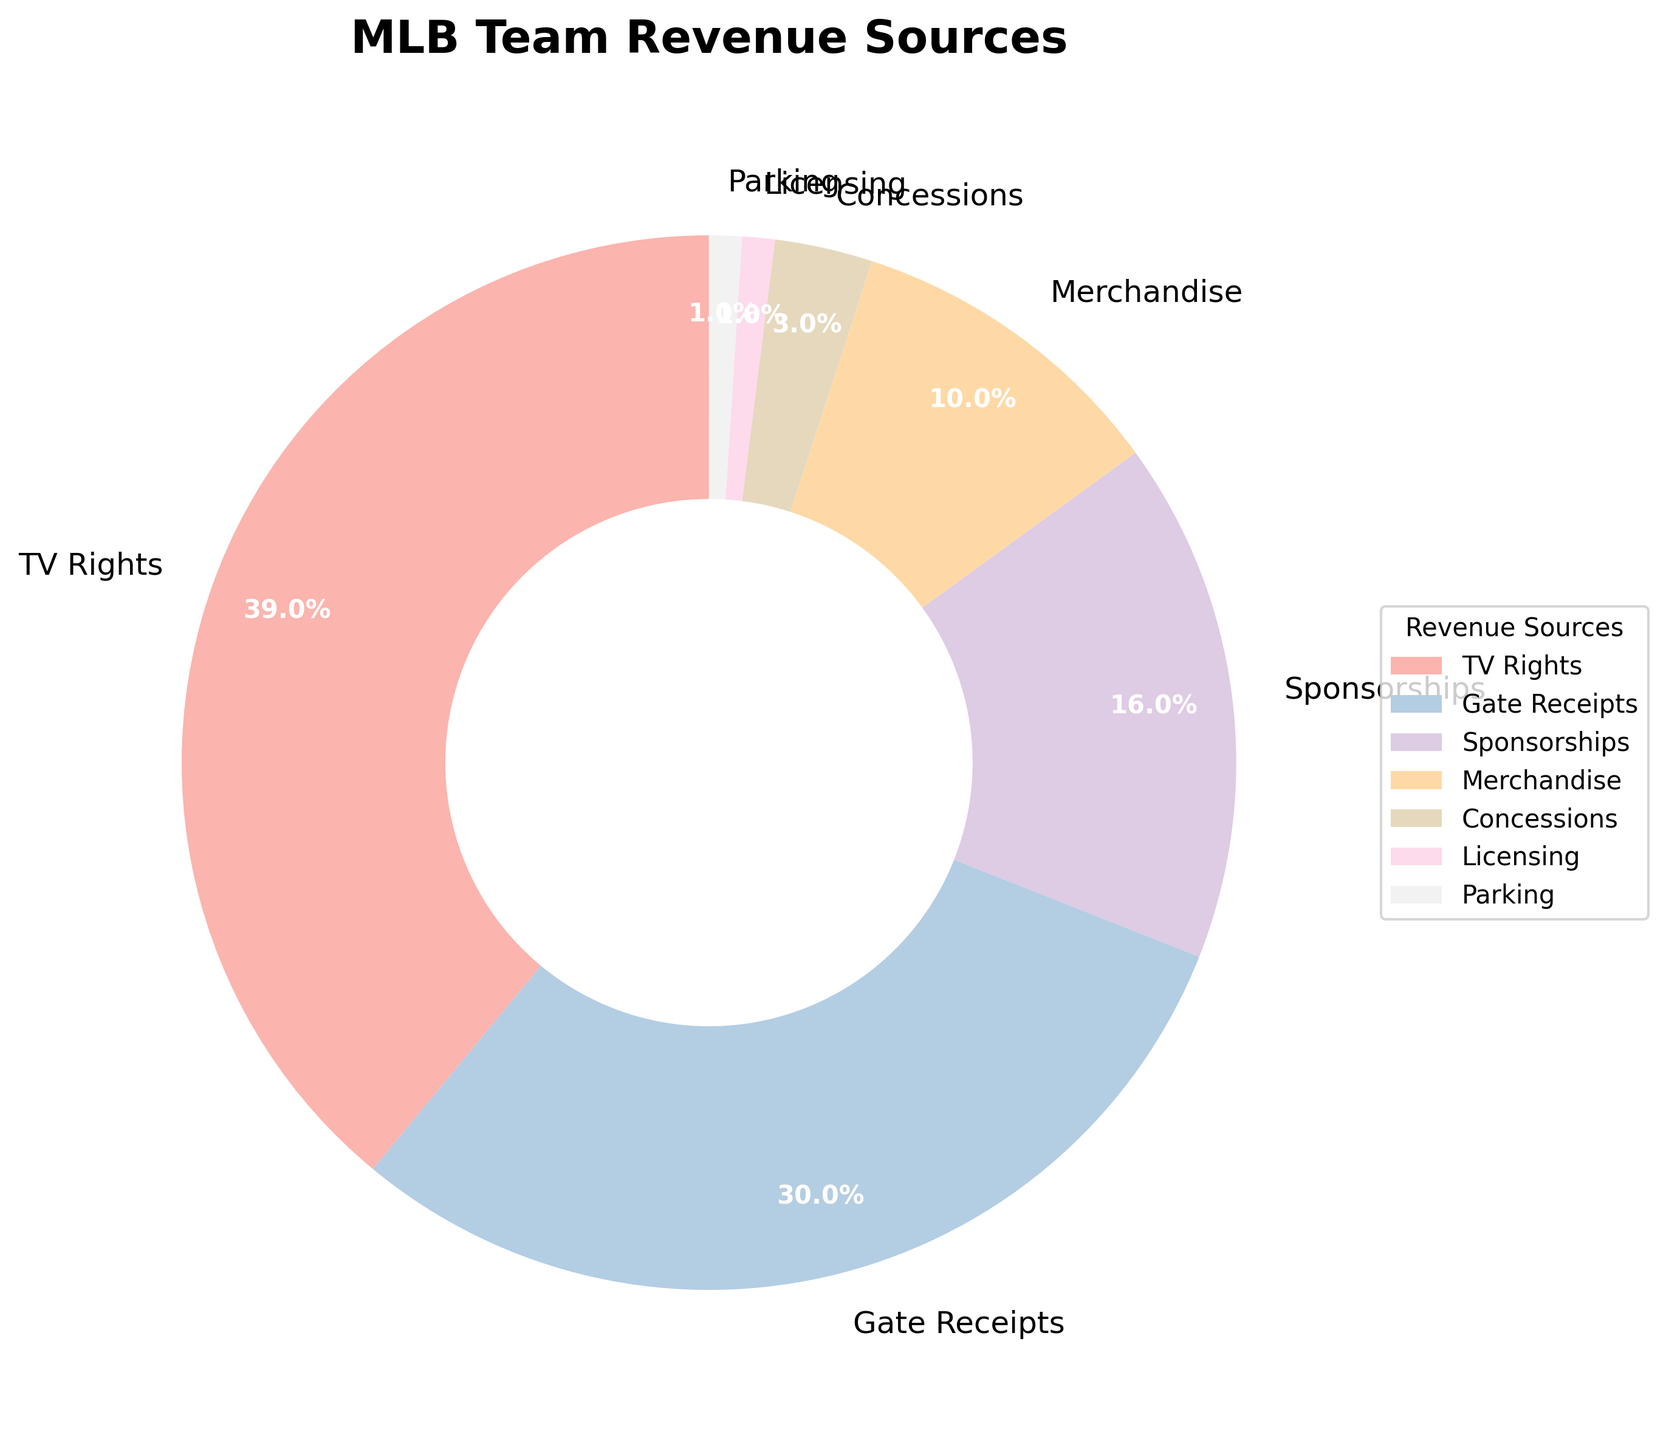Which revenue source contributes the most to MLB team revenue? The pie chart shows various revenue sources with their percentages. The largest wedge represents the highest contributor, which is TV Rights at 39%.
Answer: TV Rights What's the total percentage of revenue from ticket sales and concessions? From the chart, ticket sales (Gate Receipts) are 30% and concessions are 3%. Adding these gives 30% + 3% = 33%.
Answer: 33% Which revenue source contributes the least to MLB team revenue? The smallest wedge on the pie chart represents the lowest contributor. Both Licensing and Parking each contribute 1%, but since they're equal, either can be the answer.
Answer: Licensing (or Parking) Is the percentage of revenue from merchandise larger than from sponsorships? The chart shows merchandise revenue at 10% and sponsorship revenue at 16%. Since 10% is less than 16%, merchandise revenue is not larger.
Answer: No What is the combined percentage for non-ticket, non-TV revenue sources? Excluding Gate Receipts (30%) and TV Rights (39%), sum the other sources: Sponsorships (16%) + Merchandise (10%) + Concessions (3%) + Licensing (1%) + Parking (1%) = 31%.
Answer: 31% What is the percentage difference between TV Rights and Gate Receipts? TV Rights are 39% and Gate Receipts are 30%. The difference is 39% - 30% = 9%.
Answer: 9% Which revenue source is visually represented by the wedge with the second largest area in the pie chart? The second largest wedge after TV Rights (39%) is Gate Receipts at 30%.
Answer: Gate Receipts If the percentage of revenue from each source except Sponsorships were doubled, which revenue source would then be the largest? Doubling all but Sponsorships:
TV Rights: 39% → 78%, 
Gate Receipts: 30% → 60%, 
Merchandise: 10% → 20%, 
Concessions: 3% → 6%, 
Licensing: 1% → 2%, 
Parking: 1% → 2%. 
Since 78% (TV Rights) is the highest, TV Rights remains the largest.
Answer: TV Rights 